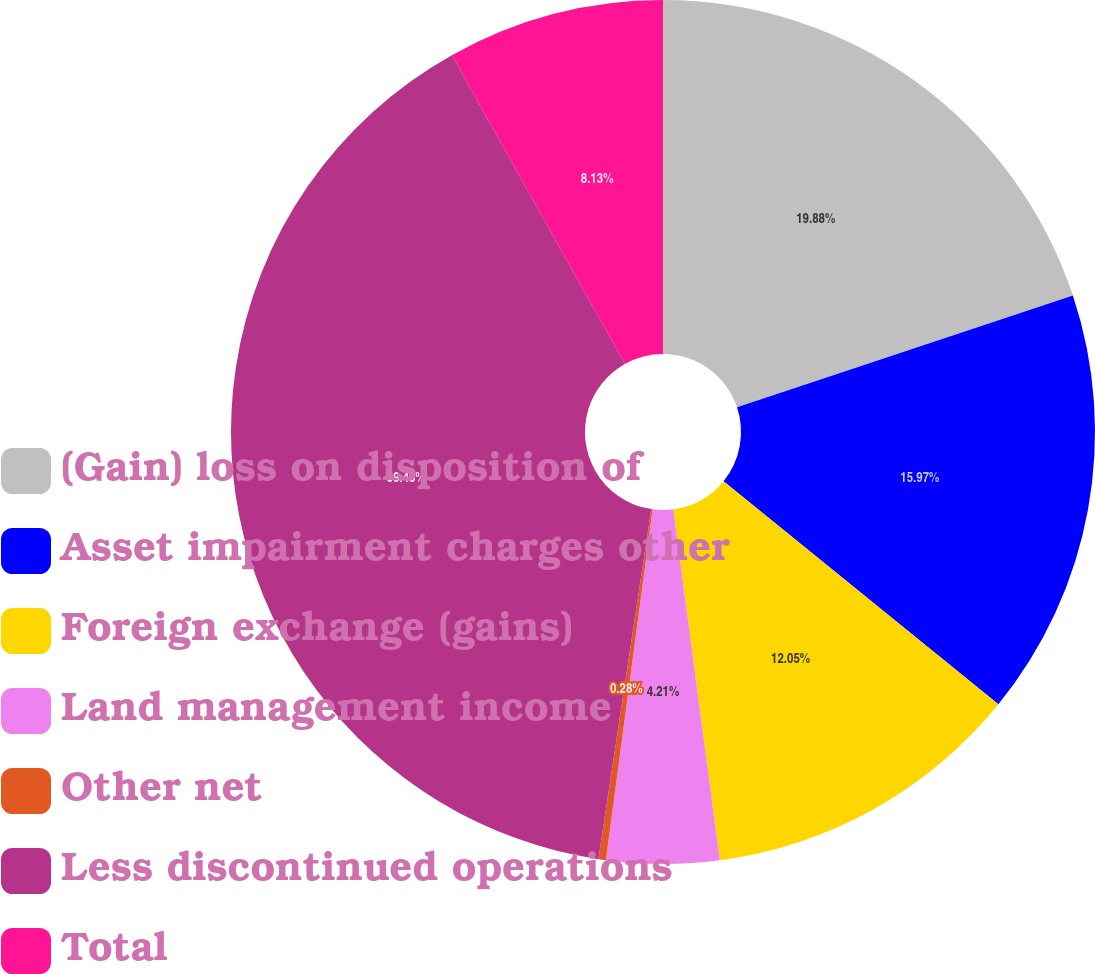Convert chart. <chart><loc_0><loc_0><loc_500><loc_500><pie_chart><fcel>(Gain) loss on disposition of<fcel>Asset impairment charges other<fcel>Foreign exchange (gains)<fcel>Land management income<fcel>Other net<fcel>Less discontinued operations<fcel>Total<nl><fcel>19.89%<fcel>15.97%<fcel>12.05%<fcel>4.21%<fcel>0.28%<fcel>39.49%<fcel>8.13%<nl></chart> 